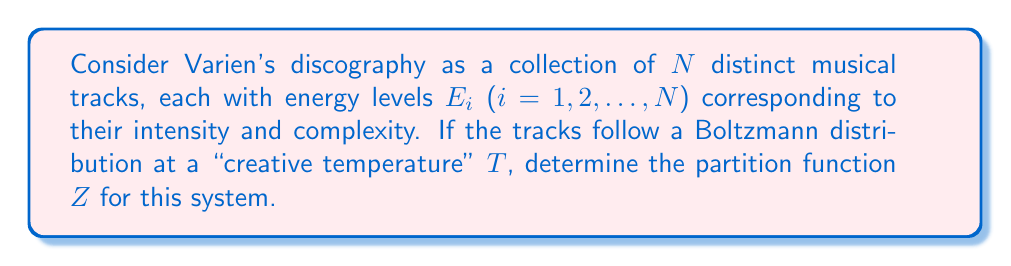Help me with this question. To solve this problem, we'll follow these steps:

1) The partition function $Z$ for a system with discrete energy levels is given by:

   $$Z = \sum_i e^{-\beta E_i}$$

   where $\beta = \frac{1}{k_B T}$, $k_B$ is Boltzmann's constant, and $T$ is the temperature.

2) In our case, each "particle" represents a track in Varien's discography, and each has a unique energy level $E_i$.

3) Since we have $N$ distinct tracks, our partition function becomes:

   $$Z = \sum_{i=1}^N e^{-\beta E_i}$$

4) We can't simplify this further without knowing the specific energy levels of each track. However, we can express it in terms of the "creative temperature" $T$:

   $$Z = \sum_{i=1}^N e^{-E_i/(k_B T)}$$

5) This form of the partition function takes into account the unique energy (intensity and complexity) of each track in Varien's discography, weighted by the "creative temperature" that represents the overall energy level of the artist's work.
Answer: $$Z = \sum_{i=1}^N e^{-E_i/(k_B T)}$$ 